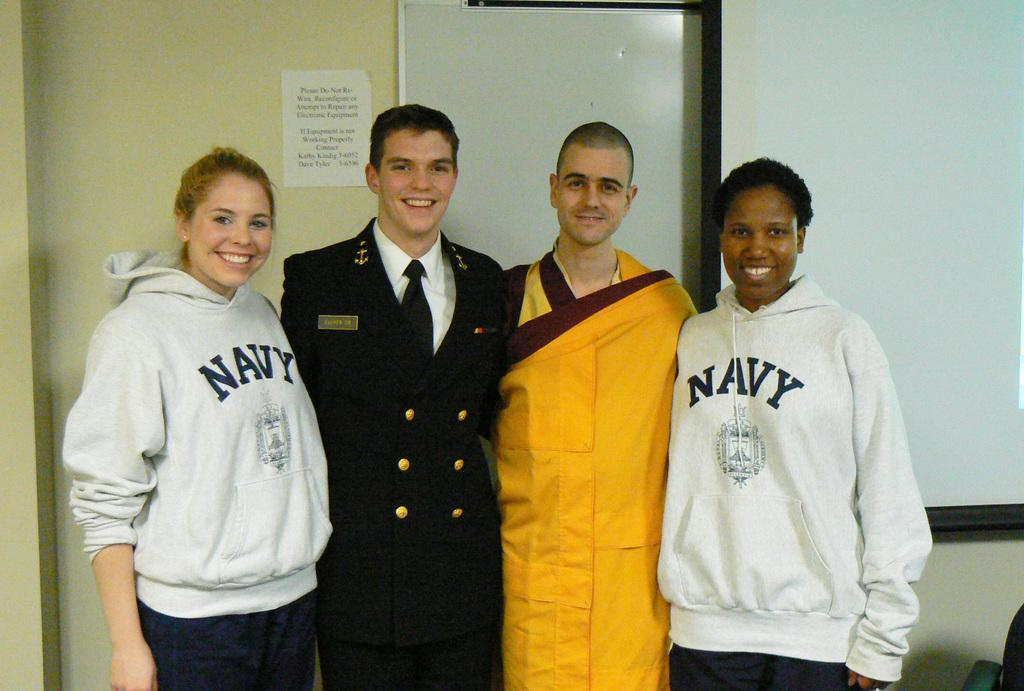How many people are in the image? There are four people in the image, two men and two women. What are the people in the image doing? The people are standing and smiling. What can be seen in the background of the image? There is a wall, a poster, and a screen in the background of the image. What type of toys can be seen on the screen in the image? There are no toys visible on the screen in the image. 